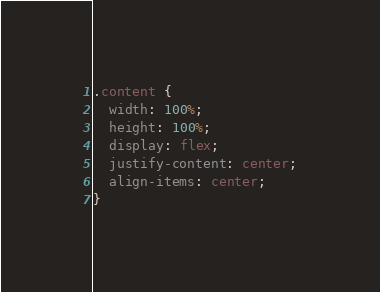<code> <loc_0><loc_0><loc_500><loc_500><_CSS_>.content {
  width: 100%;
  height: 100%;
  display: flex;
  justify-content: center;
  align-items: center;
}</code> 